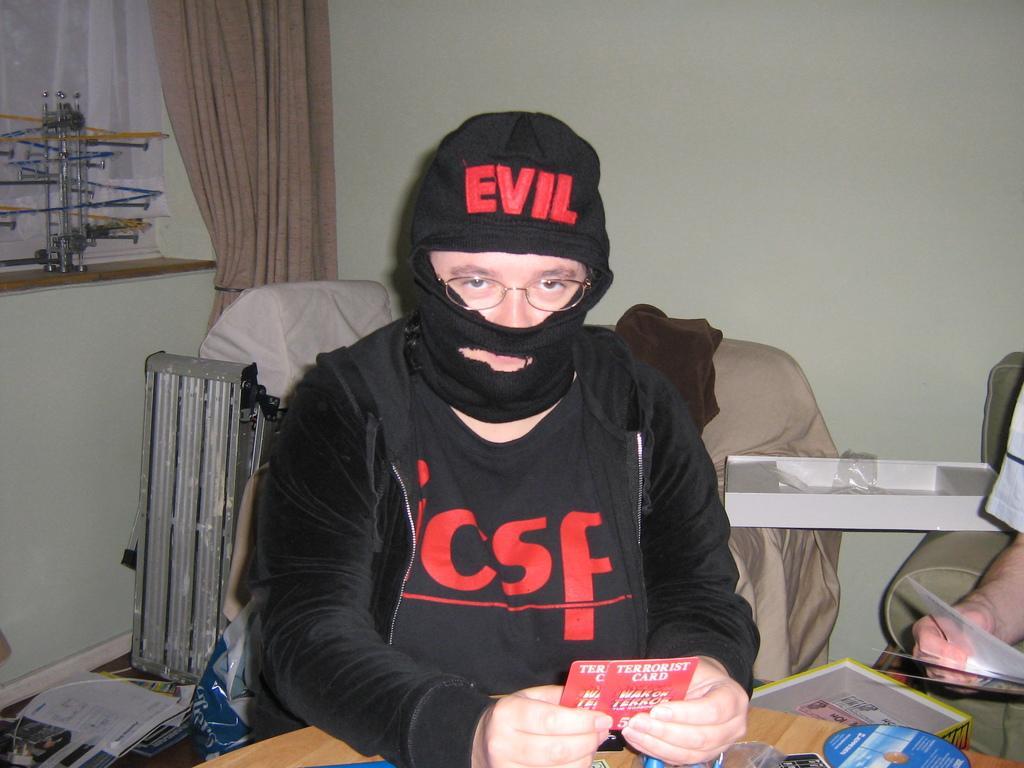How would you summarize this image in a sentence or two? This image consists of a person in the middle. There is a table in front of him. There is a CD at the bottom. There is another person's hand on the right side. 